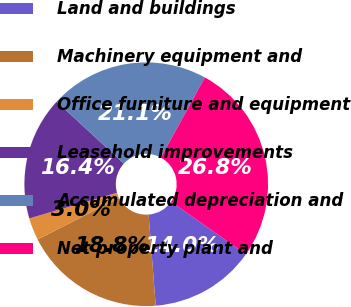Convert chart. <chart><loc_0><loc_0><loc_500><loc_500><pie_chart><fcel>Land and buildings<fcel>Machinery equipment and<fcel>Office furniture and equipment<fcel>Leasehold improvements<fcel>Accumulated depreciation and<fcel>Net property plant and<nl><fcel>14.0%<fcel>18.76%<fcel>2.96%<fcel>16.38%<fcel>21.14%<fcel>26.76%<nl></chart> 